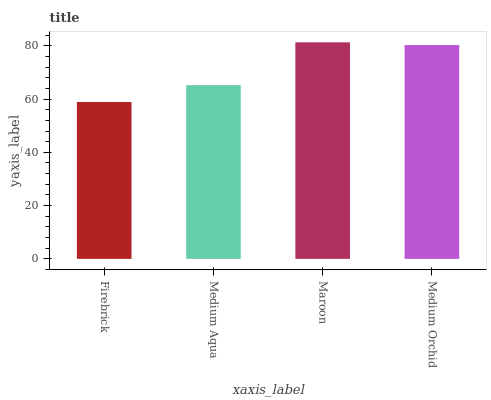Is Firebrick the minimum?
Answer yes or no. Yes. Is Maroon the maximum?
Answer yes or no. Yes. Is Medium Aqua the minimum?
Answer yes or no. No. Is Medium Aqua the maximum?
Answer yes or no. No. Is Medium Aqua greater than Firebrick?
Answer yes or no. Yes. Is Firebrick less than Medium Aqua?
Answer yes or no. Yes. Is Firebrick greater than Medium Aqua?
Answer yes or no. No. Is Medium Aqua less than Firebrick?
Answer yes or no. No. Is Medium Orchid the high median?
Answer yes or no. Yes. Is Medium Aqua the low median?
Answer yes or no. Yes. Is Firebrick the high median?
Answer yes or no. No. Is Medium Orchid the low median?
Answer yes or no. No. 